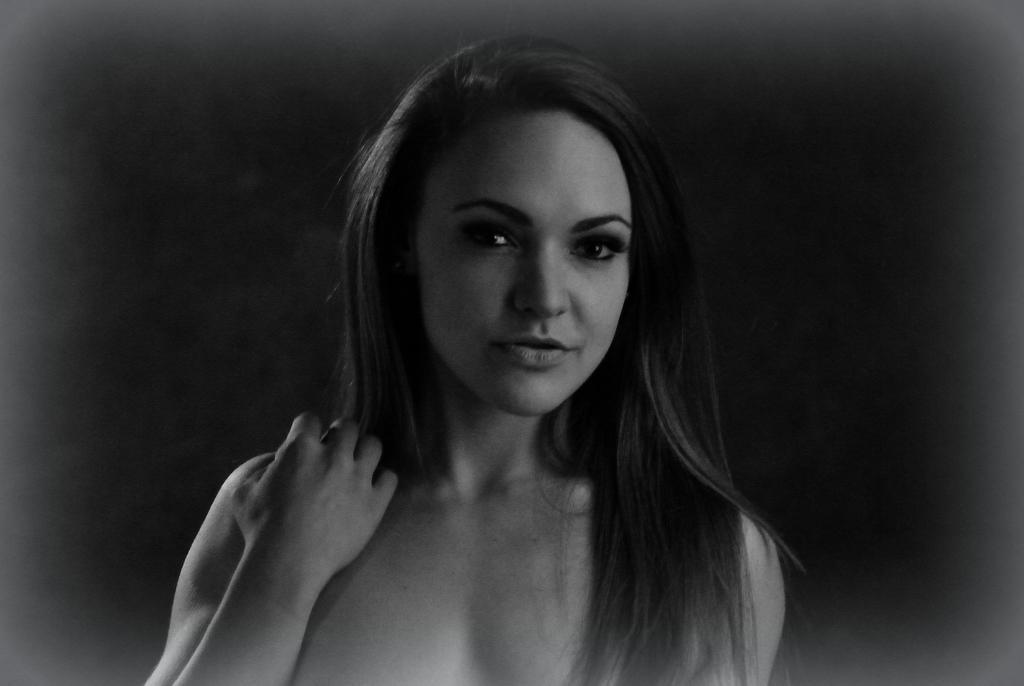Could you give a brief overview of what you see in this image? In the center of the image we can see a lady. 